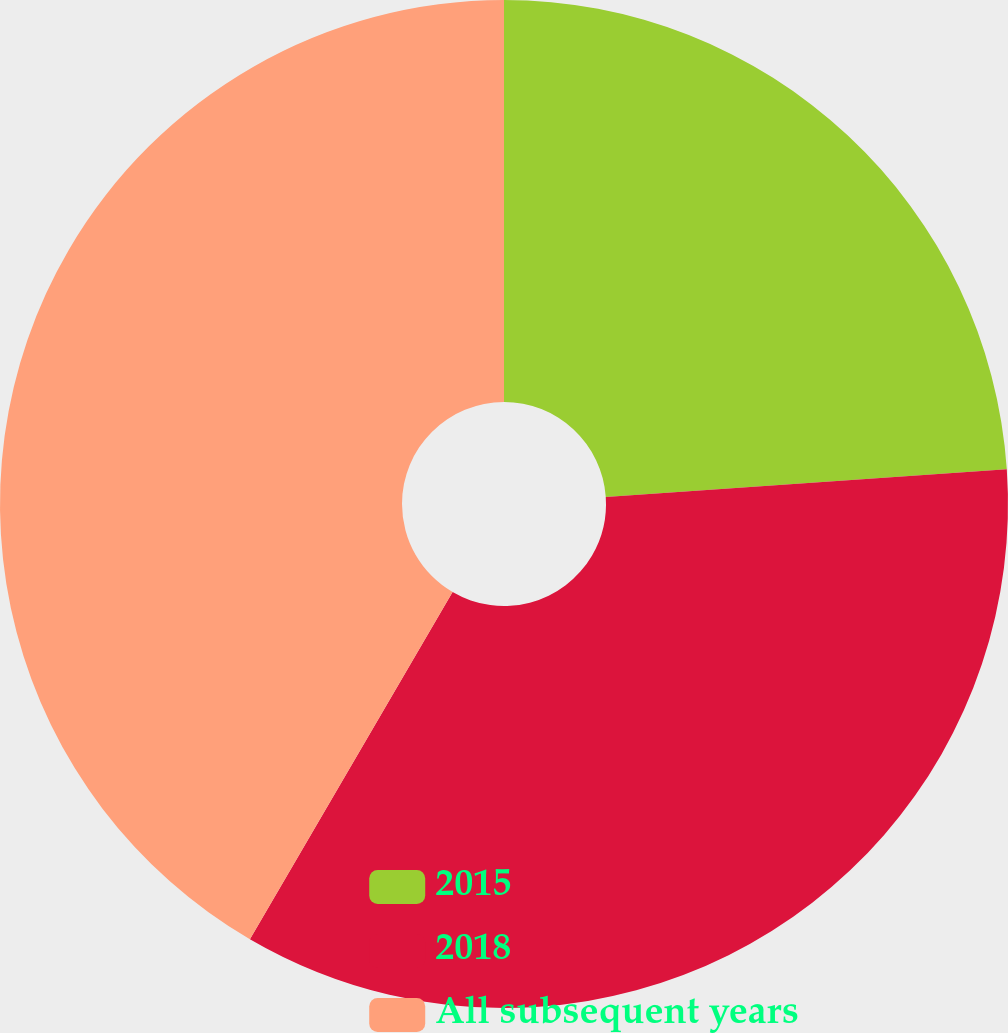<chart> <loc_0><loc_0><loc_500><loc_500><pie_chart><fcel>2015<fcel>2018<fcel>All subsequent years<nl><fcel>23.9%<fcel>34.51%<fcel>41.59%<nl></chart> 